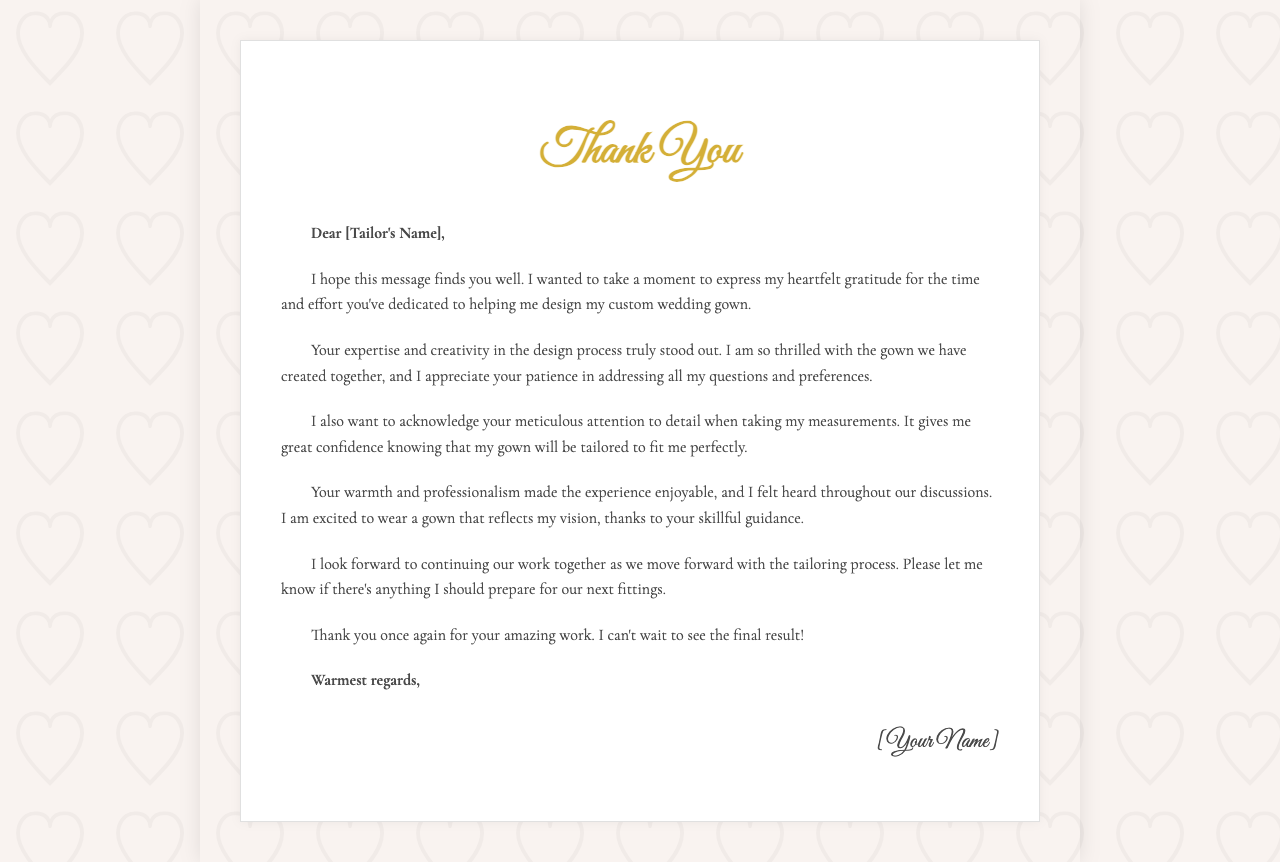What is the purpose of the letter? The letter expresses gratitude towards the tailor for their work on the wedding gown.
Answer: Gratitude Who is the letter addressed to? The greeting indicates the letter is directed to a specific person, the tailor.
Answer: [Tailor's Name] What aspect of the tailoring process is highlighted as particularly important? The author mentions meticulous attention to detail in taking measurements.
Answer: Measurements What feeling does the author convey about the gown design process? The author expresses being thrilled with the gown created together.
Answer: Thrilled What does the author look forward to after sending this letter? The author mentions continuing work together as they move forward with the tailoring process.
Answer: Further tailoring How does the author describe the tailor's professionalism? The author states that the warmth and professionalism made the experience enjoyable.
Answer: Enjoyable What does the author request the tailor to inform them about? The author asks if there's anything they should prepare for the next fittings.
Answer: Next fittings What is the closing line of the letter? The letter concludes with a warm sign-off before the author's name.
Answer: Warmest regards Who is the person writing the letter? The signature at the end indicates the writer's identity.
Answer: [Your Name] 